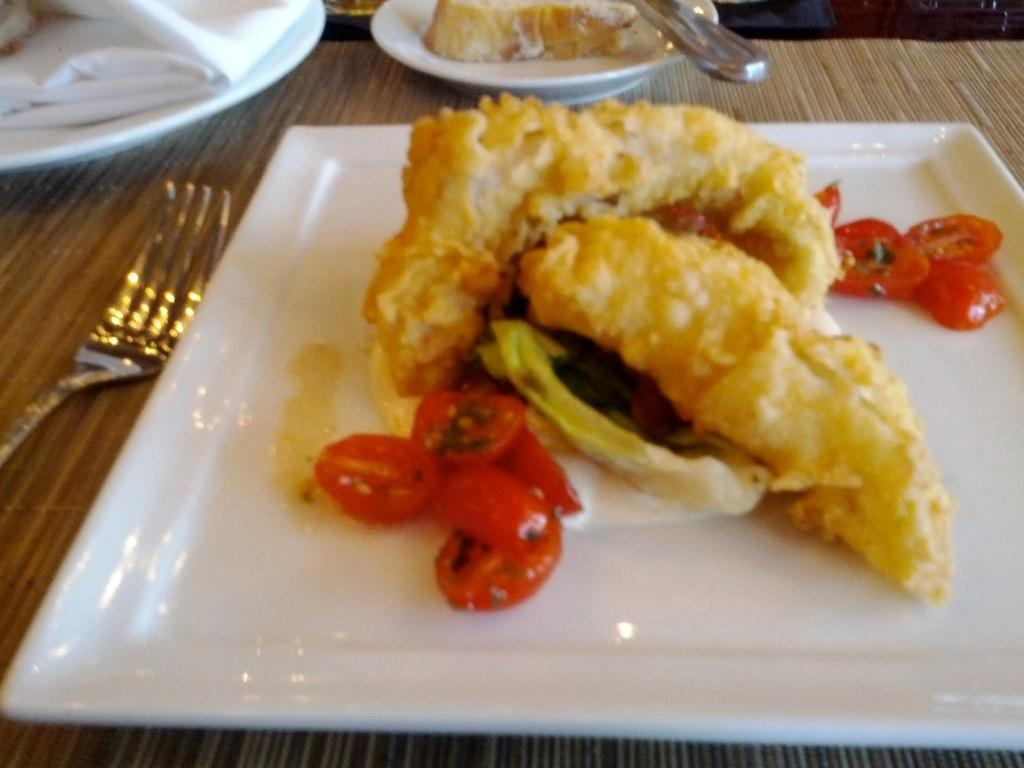What type of furniture is present in the image? There is a table in the image. What items can be seen on the table? There are plates, tissues, forks, and a food item on the table. What might be used for cleaning or wiping in the image? Tissues are present on the table for cleaning or wiping. Can you see any skirts or horses at the seashore in the image? There is no seashore, skirt, or horses present in the image. 